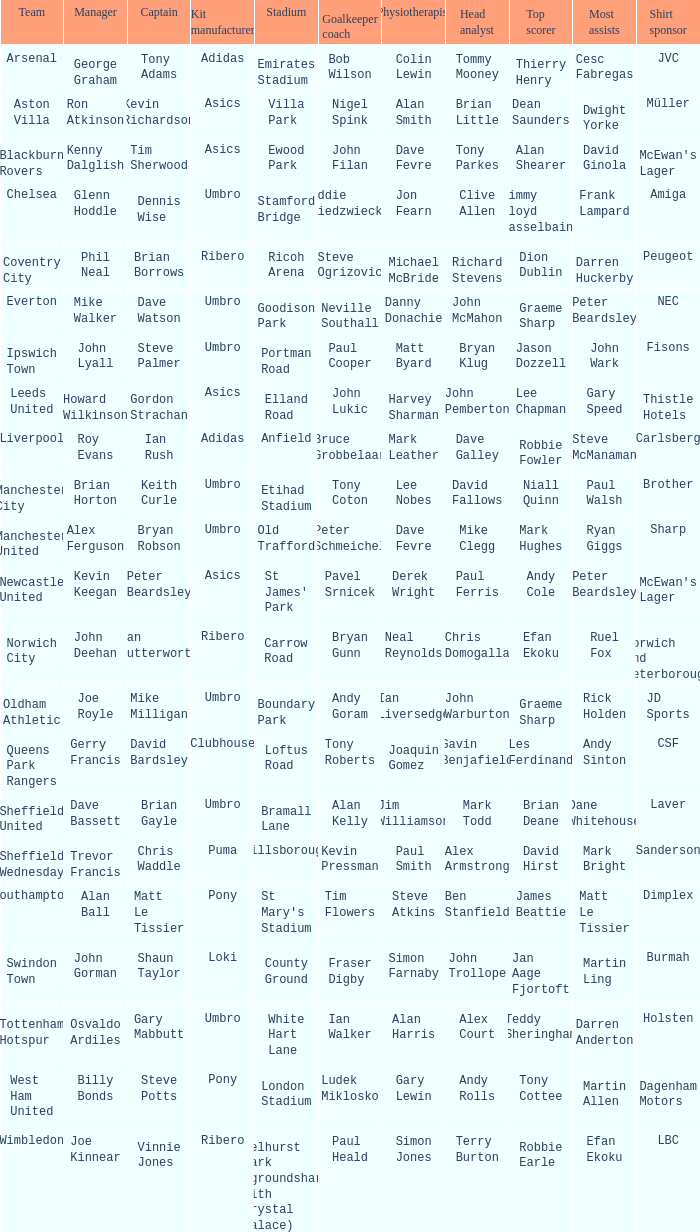Which team has george graham as the manager? Arsenal. 